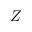<formula> <loc_0><loc_0><loc_500><loc_500>Z</formula> 